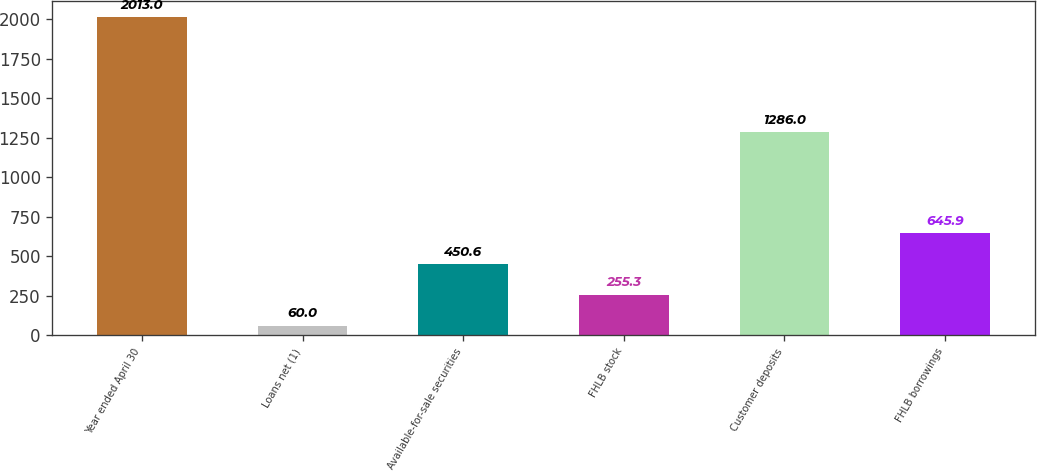<chart> <loc_0><loc_0><loc_500><loc_500><bar_chart><fcel>Year ended April 30<fcel>Loans net (1)<fcel>Available-for-sale securities<fcel>FHLB stock<fcel>Customer deposits<fcel>FHLB borrowings<nl><fcel>2013<fcel>60<fcel>450.6<fcel>255.3<fcel>1286<fcel>645.9<nl></chart> 